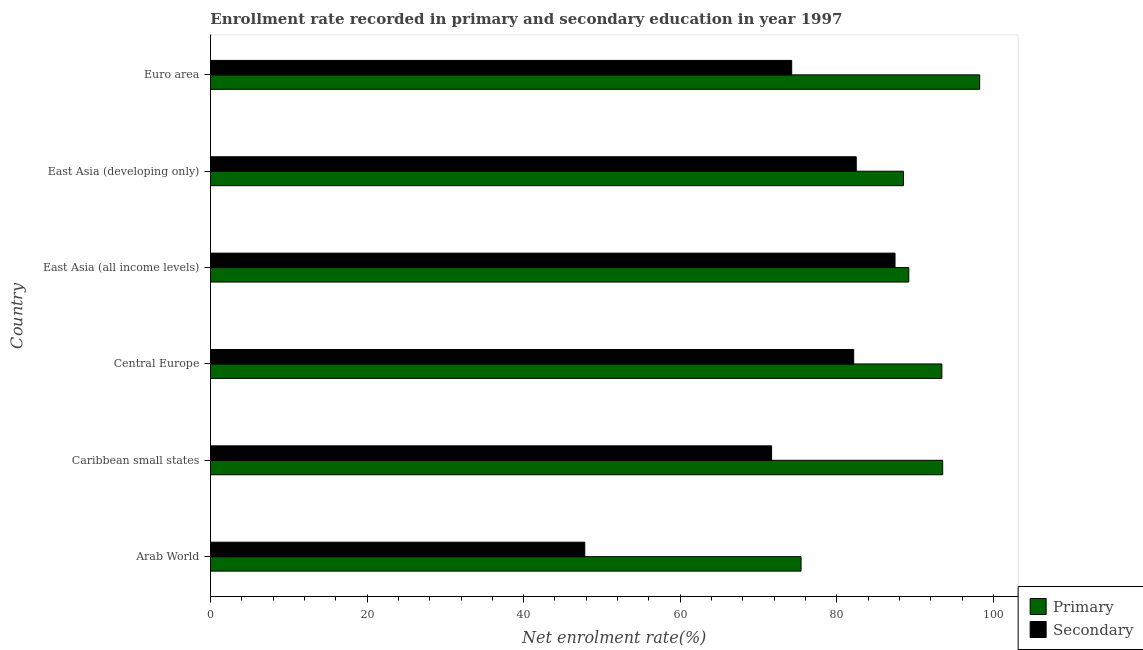How many different coloured bars are there?
Your answer should be compact. 2. How many groups of bars are there?
Provide a short and direct response. 6. How many bars are there on the 3rd tick from the bottom?
Keep it short and to the point. 2. What is the label of the 2nd group of bars from the top?
Your answer should be very brief. East Asia (developing only). In how many cases, is the number of bars for a given country not equal to the number of legend labels?
Keep it short and to the point. 0. What is the enrollment rate in secondary education in Arab World?
Your answer should be compact. 47.81. Across all countries, what is the maximum enrollment rate in secondary education?
Make the answer very short. 87.44. Across all countries, what is the minimum enrollment rate in primary education?
Make the answer very short. 75.44. In which country was the enrollment rate in secondary education maximum?
Ensure brevity in your answer.  East Asia (all income levels). In which country was the enrollment rate in primary education minimum?
Keep it short and to the point. Arab World. What is the total enrollment rate in secondary education in the graph?
Ensure brevity in your answer.  445.81. What is the difference between the enrollment rate in secondary education in Central Europe and that in Euro area?
Offer a very short reply. 7.92. What is the difference between the enrollment rate in primary education in Caribbean small states and the enrollment rate in secondary education in East Asia (developing only)?
Offer a terse response. 11.04. What is the average enrollment rate in secondary education per country?
Provide a succinct answer. 74.3. What is the difference between the enrollment rate in primary education and enrollment rate in secondary education in Caribbean small states?
Your answer should be compact. 21.85. In how many countries, is the enrollment rate in secondary education greater than 76 %?
Your answer should be compact. 3. Is the enrollment rate in secondary education in Caribbean small states less than that in Euro area?
Offer a very short reply. Yes. What is the difference between the highest and the second highest enrollment rate in secondary education?
Your answer should be compact. 4.96. What is the difference between the highest and the lowest enrollment rate in primary education?
Your response must be concise. 22.82. What does the 2nd bar from the top in East Asia (all income levels) represents?
Give a very brief answer. Primary. What does the 2nd bar from the bottom in East Asia (all income levels) represents?
Your answer should be very brief. Secondary. Are all the bars in the graph horizontal?
Your answer should be very brief. Yes. What is the difference between two consecutive major ticks on the X-axis?
Your answer should be very brief. 20. Are the values on the major ticks of X-axis written in scientific E-notation?
Give a very brief answer. No. Does the graph contain grids?
Offer a terse response. No. What is the title of the graph?
Your response must be concise. Enrollment rate recorded in primary and secondary education in year 1997. Does "From World Bank" appear as one of the legend labels in the graph?
Provide a succinct answer. No. What is the label or title of the X-axis?
Give a very brief answer. Net enrolment rate(%). What is the label or title of the Y-axis?
Ensure brevity in your answer.  Country. What is the Net enrolment rate(%) in Primary in Arab World?
Offer a terse response. 75.44. What is the Net enrolment rate(%) of Secondary in Arab World?
Provide a succinct answer. 47.81. What is the Net enrolment rate(%) of Primary in Caribbean small states?
Your response must be concise. 93.53. What is the Net enrolment rate(%) in Secondary in Caribbean small states?
Offer a very short reply. 71.67. What is the Net enrolment rate(%) in Primary in Central Europe?
Provide a short and direct response. 93.42. What is the Net enrolment rate(%) of Secondary in Central Europe?
Your answer should be compact. 82.16. What is the Net enrolment rate(%) of Primary in East Asia (all income levels)?
Provide a succinct answer. 89.2. What is the Net enrolment rate(%) in Secondary in East Asia (all income levels)?
Provide a short and direct response. 87.44. What is the Net enrolment rate(%) of Primary in East Asia (developing only)?
Offer a very short reply. 88.51. What is the Net enrolment rate(%) of Secondary in East Asia (developing only)?
Make the answer very short. 82.48. What is the Net enrolment rate(%) in Primary in Euro area?
Keep it short and to the point. 98.25. What is the Net enrolment rate(%) in Secondary in Euro area?
Give a very brief answer. 74.24. Across all countries, what is the maximum Net enrolment rate(%) in Primary?
Keep it short and to the point. 98.25. Across all countries, what is the maximum Net enrolment rate(%) of Secondary?
Offer a terse response. 87.44. Across all countries, what is the minimum Net enrolment rate(%) of Primary?
Ensure brevity in your answer.  75.44. Across all countries, what is the minimum Net enrolment rate(%) of Secondary?
Your answer should be very brief. 47.81. What is the total Net enrolment rate(%) in Primary in the graph?
Provide a succinct answer. 538.34. What is the total Net enrolment rate(%) in Secondary in the graph?
Keep it short and to the point. 445.81. What is the difference between the Net enrolment rate(%) of Primary in Arab World and that in Caribbean small states?
Ensure brevity in your answer.  -18.09. What is the difference between the Net enrolment rate(%) in Secondary in Arab World and that in Caribbean small states?
Your answer should be compact. -23.86. What is the difference between the Net enrolment rate(%) in Primary in Arab World and that in Central Europe?
Provide a succinct answer. -17.98. What is the difference between the Net enrolment rate(%) in Secondary in Arab World and that in Central Europe?
Your response must be concise. -34.35. What is the difference between the Net enrolment rate(%) of Primary in Arab World and that in East Asia (all income levels)?
Offer a very short reply. -13.76. What is the difference between the Net enrolment rate(%) of Secondary in Arab World and that in East Asia (all income levels)?
Offer a terse response. -39.63. What is the difference between the Net enrolment rate(%) in Primary in Arab World and that in East Asia (developing only)?
Your answer should be compact. -13.08. What is the difference between the Net enrolment rate(%) in Secondary in Arab World and that in East Asia (developing only)?
Offer a terse response. -34.67. What is the difference between the Net enrolment rate(%) in Primary in Arab World and that in Euro area?
Give a very brief answer. -22.82. What is the difference between the Net enrolment rate(%) in Secondary in Arab World and that in Euro area?
Provide a short and direct response. -26.43. What is the difference between the Net enrolment rate(%) in Primary in Caribbean small states and that in Central Europe?
Provide a succinct answer. 0.11. What is the difference between the Net enrolment rate(%) of Secondary in Caribbean small states and that in Central Europe?
Make the answer very short. -10.49. What is the difference between the Net enrolment rate(%) in Primary in Caribbean small states and that in East Asia (all income levels)?
Give a very brief answer. 4.33. What is the difference between the Net enrolment rate(%) of Secondary in Caribbean small states and that in East Asia (all income levels)?
Keep it short and to the point. -15.77. What is the difference between the Net enrolment rate(%) of Primary in Caribbean small states and that in East Asia (developing only)?
Keep it short and to the point. 5.01. What is the difference between the Net enrolment rate(%) of Secondary in Caribbean small states and that in East Asia (developing only)?
Offer a very short reply. -10.81. What is the difference between the Net enrolment rate(%) of Primary in Caribbean small states and that in Euro area?
Ensure brevity in your answer.  -4.73. What is the difference between the Net enrolment rate(%) of Secondary in Caribbean small states and that in Euro area?
Ensure brevity in your answer.  -2.57. What is the difference between the Net enrolment rate(%) in Primary in Central Europe and that in East Asia (all income levels)?
Make the answer very short. 4.22. What is the difference between the Net enrolment rate(%) in Secondary in Central Europe and that in East Asia (all income levels)?
Your answer should be compact. -5.28. What is the difference between the Net enrolment rate(%) of Primary in Central Europe and that in East Asia (developing only)?
Provide a short and direct response. 4.91. What is the difference between the Net enrolment rate(%) in Secondary in Central Europe and that in East Asia (developing only)?
Offer a terse response. -0.32. What is the difference between the Net enrolment rate(%) in Primary in Central Europe and that in Euro area?
Your response must be concise. -4.83. What is the difference between the Net enrolment rate(%) of Secondary in Central Europe and that in Euro area?
Your response must be concise. 7.92. What is the difference between the Net enrolment rate(%) in Primary in East Asia (all income levels) and that in East Asia (developing only)?
Offer a very short reply. 0.69. What is the difference between the Net enrolment rate(%) of Secondary in East Asia (all income levels) and that in East Asia (developing only)?
Your response must be concise. 4.95. What is the difference between the Net enrolment rate(%) in Primary in East Asia (all income levels) and that in Euro area?
Ensure brevity in your answer.  -9.05. What is the difference between the Net enrolment rate(%) in Secondary in East Asia (all income levels) and that in Euro area?
Offer a very short reply. 13.2. What is the difference between the Net enrolment rate(%) of Primary in East Asia (developing only) and that in Euro area?
Offer a terse response. -9.74. What is the difference between the Net enrolment rate(%) in Secondary in East Asia (developing only) and that in Euro area?
Provide a short and direct response. 8.24. What is the difference between the Net enrolment rate(%) in Primary in Arab World and the Net enrolment rate(%) in Secondary in Caribbean small states?
Ensure brevity in your answer.  3.76. What is the difference between the Net enrolment rate(%) of Primary in Arab World and the Net enrolment rate(%) of Secondary in Central Europe?
Make the answer very short. -6.73. What is the difference between the Net enrolment rate(%) of Primary in Arab World and the Net enrolment rate(%) of Secondary in East Asia (all income levels)?
Ensure brevity in your answer.  -12. What is the difference between the Net enrolment rate(%) of Primary in Arab World and the Net enrolment rate(%) of Secondary in East Asia (developing only)?
Offer a very short reply. -7.05. What is the difference between the Net enrolment rate(%) in Primary in Arab World and the Net enrolment rate(%) in Secondary in Euro area?
Give a very brief answer. 1.2. What is the difference between the Net enrolment rate(%) in Primary in Caribbean small states and the Net enrolment rate(%) in Secondary in Central Europe?
Your response must be concise. 11.37. What is the difference between the Net enrolment rate(%) of Primary in Caribbean small states and the Net enrolment rate(%) of Secondary in East Asia (all income levels)?
Your response must be concise. 6.09. What is the difference between the Net enrolment rate(%) of Primary in Caribbean small states and the Net enrolment rate(%) of Secondary in East Asia (developing only)?
Your answer should be very brief. 11.04. What is the difference between the Net enrolment rate(%) in Primary in Caribbean small states and the Net enrolment rate(%) in Secondary in Euro area?
Ensure brevity in your answer.  19.29. What is the difference between the Net enrolment rate(%) of Primary in Central Europe and the Net enrolment rate(%) of Secondary in East Asia (all income levels)?
Keep it short and to the point. 5.98. What is the difference between the Net enrolment rate(%) of Primary in Central Europe and the Net enrolment rate(%) of Secondary in East Asia (developing only)?
Ensure brevity in your answer.  10.93. What is the difference between the Net enrolment rate(%) in Primary in Central Europe and the Net enrolment rate(%) in Secondary in Euro area?
Offer a very short reply. 19.18. What is the difference between the Net enrolment rate(%) in Primary in East Asia (all income levels) and the Net enrolment rate(%) in Secondary in East Asia (developing only)?
Offer a very short reply. 6.71. What is the difference between the Net enrolment rate(%) of Primary in East Asia (all income levels) and the Net enrolment rate(%) of Secondary in Euro area?
Keep it short and to the point. 14.96. What is the difference between the Net enrolment rate(%) in Primary in East Asia (developing only) and the Net enrolment rate(%) in Secondary in Euro area?
Keep it short and to the point. 14.27. What is the average Net enrolment rate(%) in Primary per country?
Your answer should be compact. 89.72. What is the average Net enrolment rate(%) in Secondary per country?
Offer a terse response. 74.3. What is the difference between the Net enrolment rate(%) of Primary and Net enrolment rate(%) of Secondary in Arab World?
Make the answer very short. 27.62. What is the difference between the Net enrolment rate(%) of Primary and Net enrolment rate(%) of Secondary in Caribbean small states?
Your response must be concise. 21.85. What is the difference between the Net enrolment rate(%) in Primary and Net enrolment rate(%) in Secondary in Central Europe?
Your answer should be very brief. 11.26. What is the difference between the Net enrolment rate(%) of Primary and Net enrolment rate(%) of Secondary in East Asia (all income levels)?
Offer a very short reply. 1.76. What is the difference between the Net enrolment rate(%) of Primary and Net enrolment rate(%) of Secondary in East Asia (developing only)?
Your response must be concise. 6.03. What is the difference between the Net enrolment rate(%) in Primary and Net enrolment rate(%) in Secondary in Euro area?
Your answer should be compact. 24.01. What is the ratio of the Net enrolment rate(%) of Primary in Arab World to that in Caribbean small states?
Your answer should be compact. 0.81. What is the ratio of the Net enrolment rate(%) in Secondary in Arab World to that in Caribbean small states?
Your answer should be compact. 0.67. What is the ratio of the Net enrolment rate(%) in Primary in Arab World to that in Central Europe?
Make the answer very short. 0.81. What is the ratio of the Net enrolment rate(%) in Secondary in Arab World to that in Central Europe?
Offer a terse response. 0.58. What is the ratio of the Net enrolment rate(%) of Primary in Arab World to that in East Asia (all income levels)?
Provide a short and direct response. 0.85. What is the ratio of the Net enrolment rate(%) in Secondary in Arab World to that in East Asia (all income levels)?
Make the answer very short. 0.55. What is the ratio of the Net enrolment rate(%) of Primary in Arab World to that in East Asia (developing only)?
Ensure brevity in your answer.  0.85. What is the ratio of the Net enrolment rate(%) of Secondary in Arab World to that in East Asia (developing only)?
Keep it short and to the point. 0.58. What is the ratio of the Net enrolment rate(%) in Primary in Arab World to that in Euro area?
Your response must be concise. 0.77. What is the ratio of the Net enrolment rate(%) of Secondary in Arab World to that in Euro area?
Keep it short and to the point. 0.64. What is the ratio of the Net enrolment rate(%) of Primary in Caribbean small states to that in Central Europe?
Provide a succinct answer. 1. What is the ratio of the Net enrolment rate(%) of Secondary in Caribbean small states to that in Central Europe?
Make the answer very short. 0.87. What is the ratio of the Net enrolment rate(%) of Primary in Caribbean small states to that in East Asia (all income levels)?
Your answer should be very brief. 1.05. What is the ratio of the Net enrolment rate(%) of Secondary in Caribbean small states to that in East Asia (all income levels)?
Provide a short and direct response. 0.82. What is the ratio of the Net enrolment rate(%) of Primary in Caribbean small states to that in East Asia (developing only)?
Provide a succinct answer. 1.06. What is the ratio of the Net enrolment rate(%) of Secondary in Caribbean small states to that in East Asia (developing only)?
Your answer should be compact. 0.87. What is the ratio of the Net enrolment rate(%) of Primary in Caribbean small states to that in Euro area?
Give a very brief answer. 0.95. What is the ratio of the Net enrolment rate(%) of Secondary in Caribbean small states to that in Euro area?
Ensure brevity in your answer.  0.97. What is the ratio of the Net enrolment rate(%) of Primary in Central Europe to that in East Asia (all income levels)?
Offer a terse response. 1.05. What is the ratio of the Net enrolment rate(%) in Secondary in Central Europe to that in East Asia (all income levels)?
Your answer should be very brief. 0.94. What is the ratio of the Net enrolment rate(%) in Primary in Central Europe to that in East Asia (developing only)?
Your response must be concise. 1.06. What is the ratio of the Net enrolment rate(%) of Secondary in Central Europe to that in East Asia (developing only)?
Make the answer very short. 1. What is the ratio of the Net enrolment rate(%) in Primary in Central Europe to that in Euro area?
Your answer should be very brief. 0.95. What is the ratio of the Net enrolment rate(%) of Secondary in Central Europe to that in Euro area?
Offer a terse response. 1.11. What is the ratio of the Net enrolment rate(%) of Primary in East Asia (all income levels) to that in East Asia (developing only)?
Make the answer very short. 1.01. What is the ratio of the Net enrolment rate(%) of Secondary in East Asia (all income levels) to that in East Asia (developing only)?
Provide a short and direct response. 1.06. What is the ratio of the Net enrolment rate(%) in Primary in East Asia (all income levels) to that in Euro area?
Offer a terse response. 0.91. What is the ratio of the Net enrolment rate(%) of Secondary in East Asia (all income levels) to that in Euro area?
Keep it short and to the point. 1.18. What is the ratio of the Net enrolment rate(%) in Primary in East Asia (developing only) to that in Euro area?
Your answer should be compact. 0.9. What is the difference between the highest and the second highest Net enrolment rate(%) of Primary?
Make the answer very short. 4.73. What is the difference between the highest and the second highest Net enrolment rate(%) of Secondary?
Offer a terse response. 4.95. What is the difference between the highest and the lowest Net enrolment rate(%) in Primary?
Your response must be concise. 22.82. What is the difference between the highest and the lowest Net enrolment rate(%) in Secondary?
Your response must be concise. 39.63. 